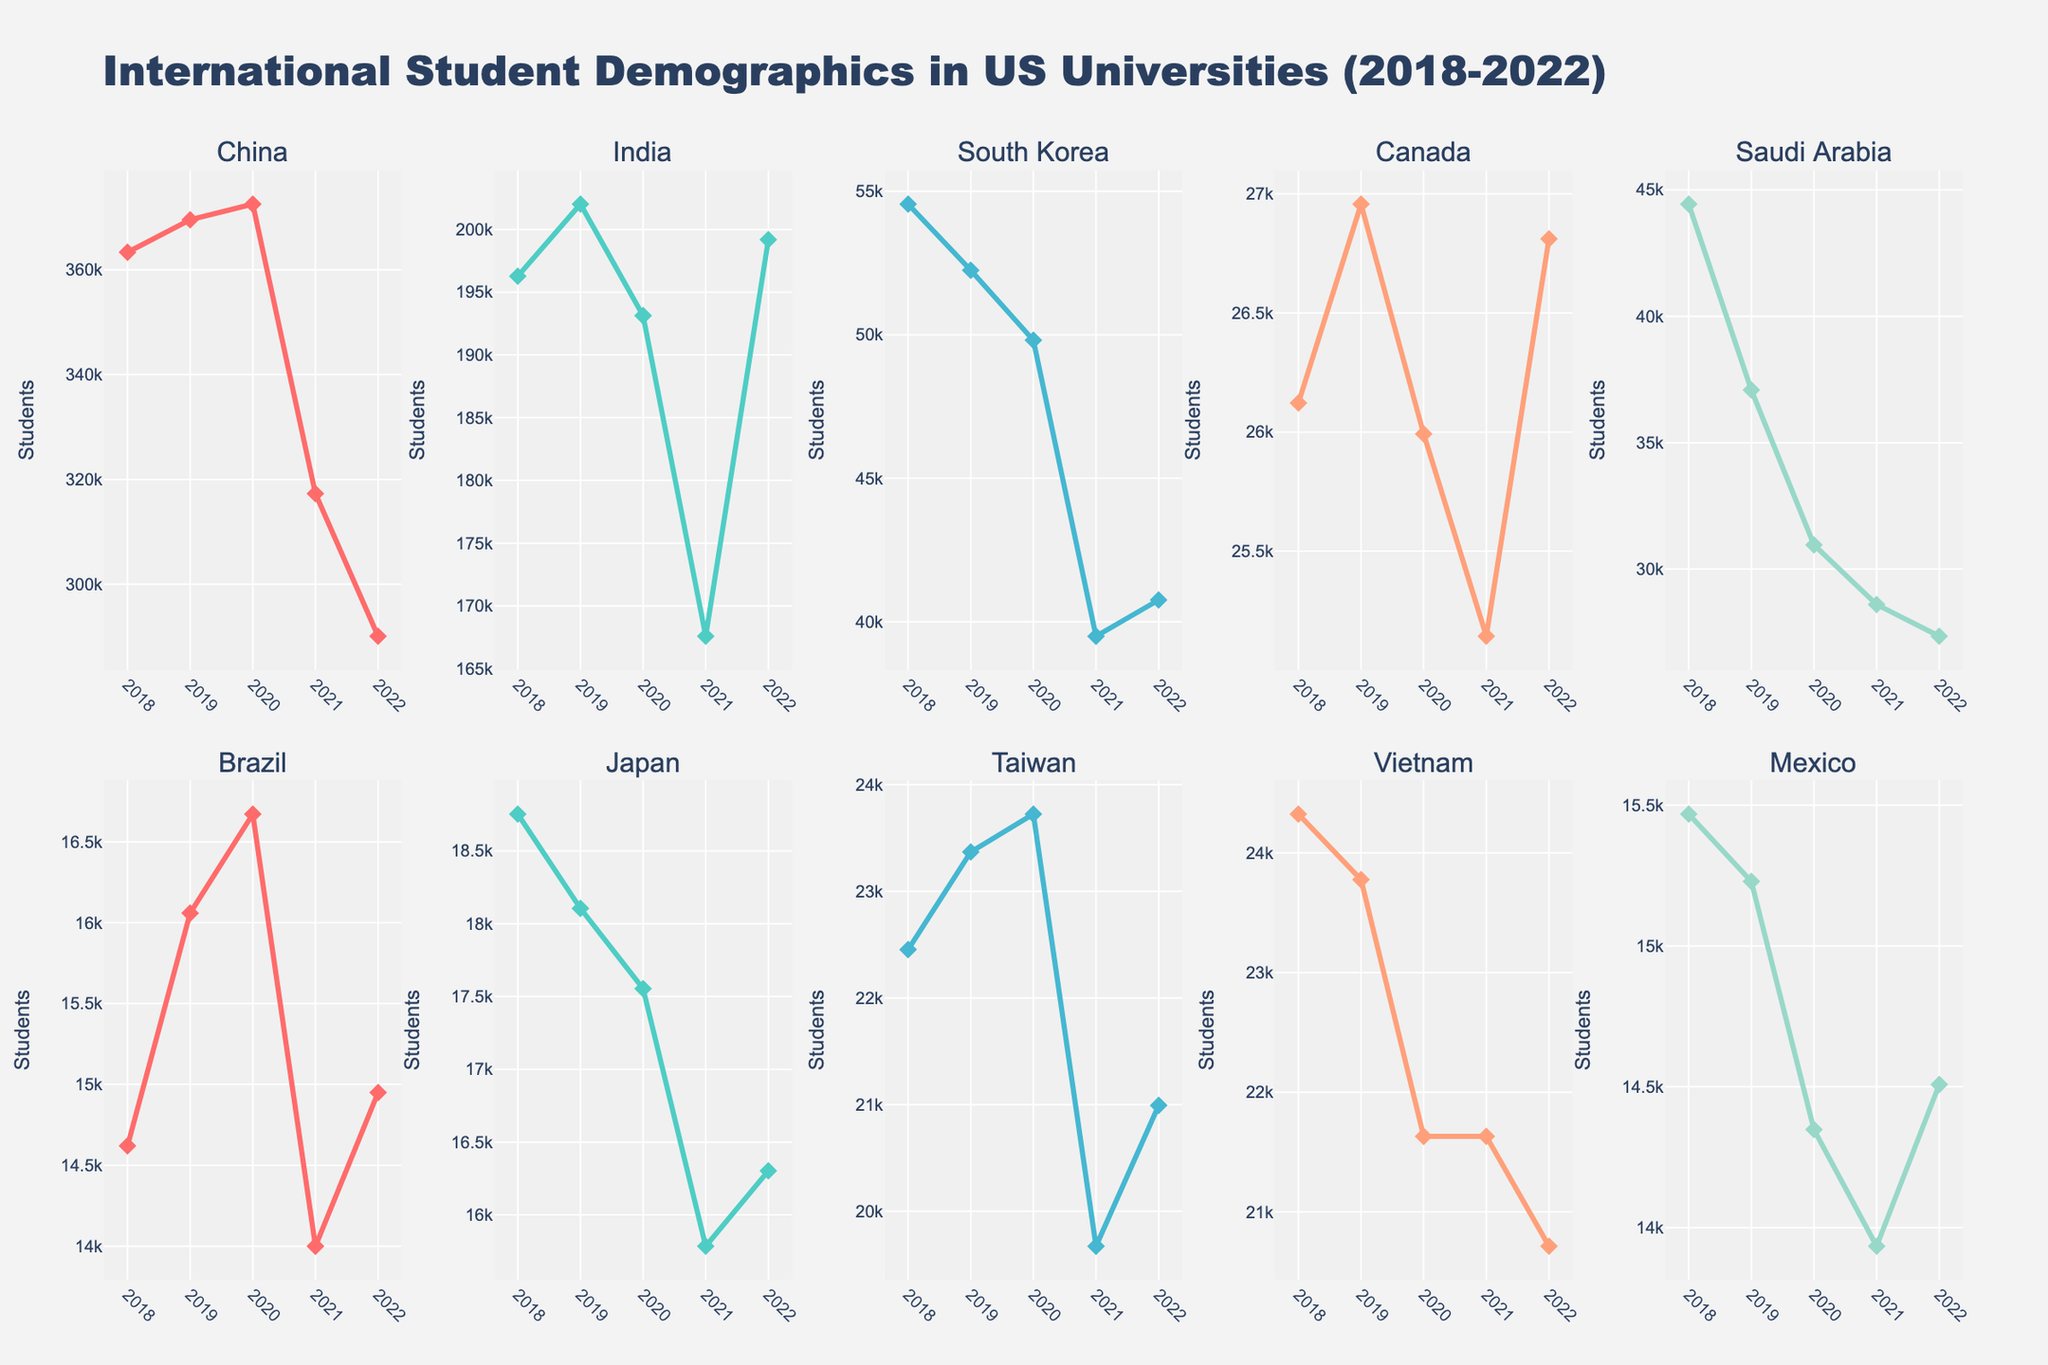what is the title of the plot? The title of the plot is centrally placed at the top of the figure and reads "Carbon Footprint Reduction: Sustainable vs Traditional Ranching Practices".
Answer: Carbon Footprint Reduction: Sustainable vs Traditional Ranching Practices how many plot titles are there in the figure? The figure consists of subplots, each with its own specific title representing a different nature practice. Count the subplot titles just above each plot.
Answer: 3 In which subplot do we see the greatest reduction in the carbon footprint from 2018 to 2022 for sustainable practice? Compare the decline in the carbon footprint for the sustainable practices from the different subplots. The steepest decline is noted in the subplot where sustainable carbon footprint reduction goes from 12.8 to 8.2 which is significant.
Answer: Rotational Grazing What was the traditional carbon footprint for improved feed management in 2020? Locate the Improved Feed Management plot and identify the point matching 2020 on the year axis. The traditional carbon footprint for this year is marked against the corresponding y-axis value.
Answer: 17.9 Which year showed the smallest carbon footprint for Manure Management in traditional practices? Look at the subplot for Manure Management and observe the data points for traditional practices. Identify the year with the lowest y-axis value.
Answer: 2022 By how much did the sustainable carbon footprint for Rotational Grazing decrease from 2018 to 2022? Check the sustainable carbon footprint for Rotational Grazing in 2018 and 2022, then calculate the difference: 12.8 in 2018 and 8.2 in 2022. Subtract the values to find the decrease.
Answer: 4.6 Which practice showed the highest traditional carbon footprint in 2021? Look at the data points for the year 2021 in each subplot and compare the traditional carbon footprint values. The highest y-axis value in 2021 indicates the practice with the highest traditional carbon footprint.
Answer: Improved Feed Management How does the sustainable carbon footprint of Manure Management compare between 2020 and 2021? Locate the Manure Management subplot and compare the data points for Sustainable practice between 2020 and 2021. Observe if there is an increase, decrease, or no change.
Answer: Decrease Which sustainable practice had the biggest difference between traditional and sustainable footprints in 2022? For each subplot, calculate the difference between traditional and sustainable data points for the year 2022. The practice with the greatest difference is the answer.
Answer: Improved Feed Management What general trend do you observe in the sustainable carbon footprints across all practices from 2018 to 2022? Examine the progression of the sustainable carbon footprint values in all three subplots over the years 2018 to 2022. Note the direction of the trend.
Answer: Decreasing 